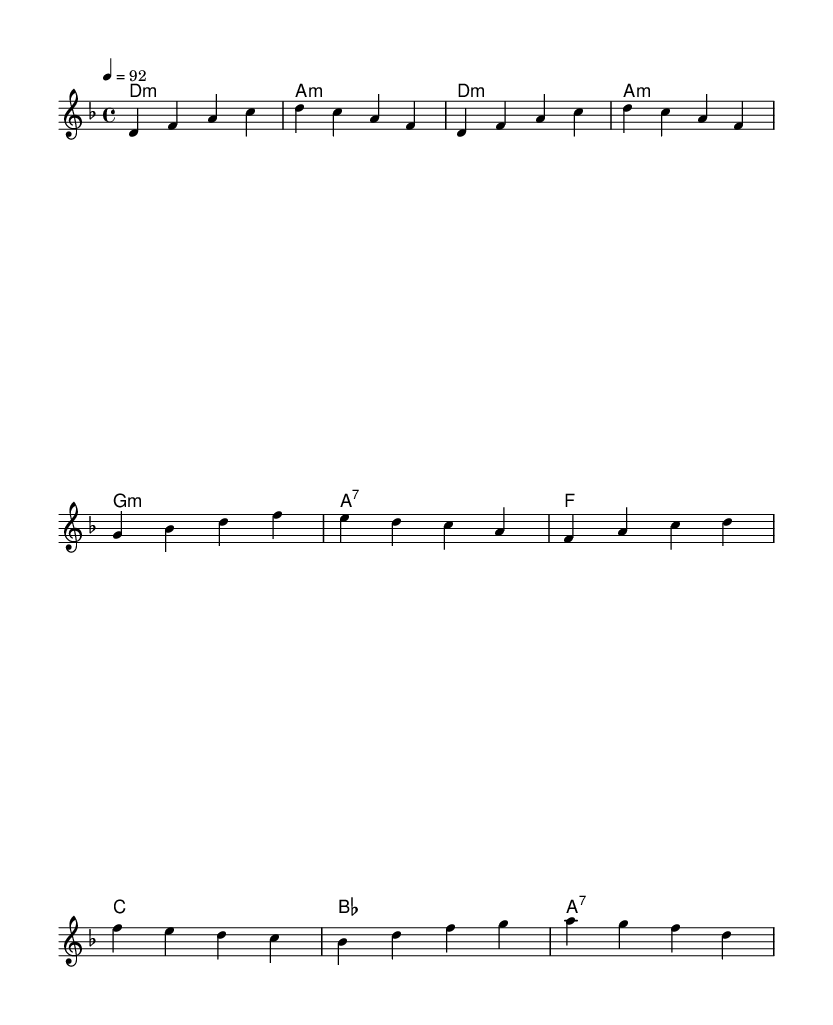What is the key signature of this music? The key signature is D minor, which contains one flat (B natural). This is determined by looking at the notes present in the melody and the harmonies, which consistently reflect the D minor scale.
Answer: D minor What is the time signature of this music? The time signature shown in the music is 4/4, indicating four beats per measure. This is confirmed by the notation that organizes the rhythm into four beats in each bar.
Answer: 4/4 What is the tempo marking of this music? The tempo marking is a quarter note equals 92 beats per minute, which is indicated at the beginning of the score. This specifies how fast the piece should be performed.
Answer: 92 How many measures are in the verse section? The verse section consists of four measures, as you can count the groups of bars specifically marked for the verse. The melody notation indicates a clear structure with repeated patterns.
Answer: 4 What type of chord is used at the beginning of the intro? The chord at the beginning of the intro is a D minor chord, which is represented by the symbol "d:m" in the chord notation. This indicates the root note and the quality of the chord.
Answer: D minor In the chorus, which chord follows the B flat chord? The chord that follows the B flat chord in the chorus is an A7 chord. This can be traced from the chord progression written under the melody during the chorus section.
Answer: A7 How many unique pitches are in the first measure? The first measure contains three unique pitches: D, F, and A, as we can list these notes directly from the melody written for that measure.
Answer: 3 